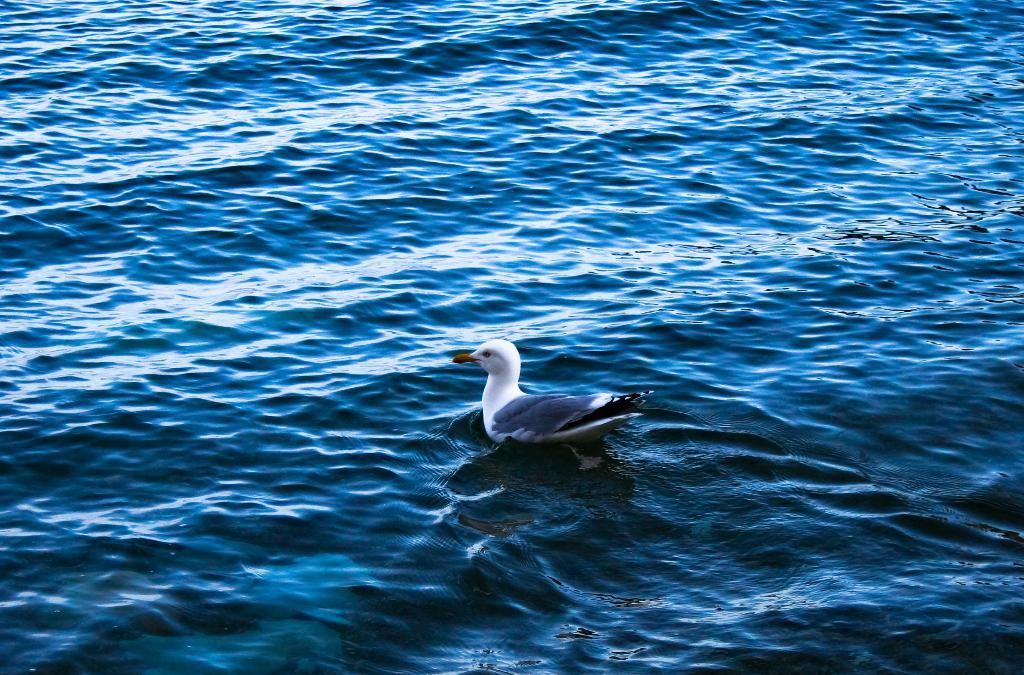What type of bird is in the image? The bird in the image is an albatross. Can you describe the albatross's location in the image? The albatross is in the water. What type of dog can be seen holding a banana in the image? There is no dog or banana present in the image; it features an albatross in the water. Is there a vase visible in the image? No, there is no vase present in the image. 